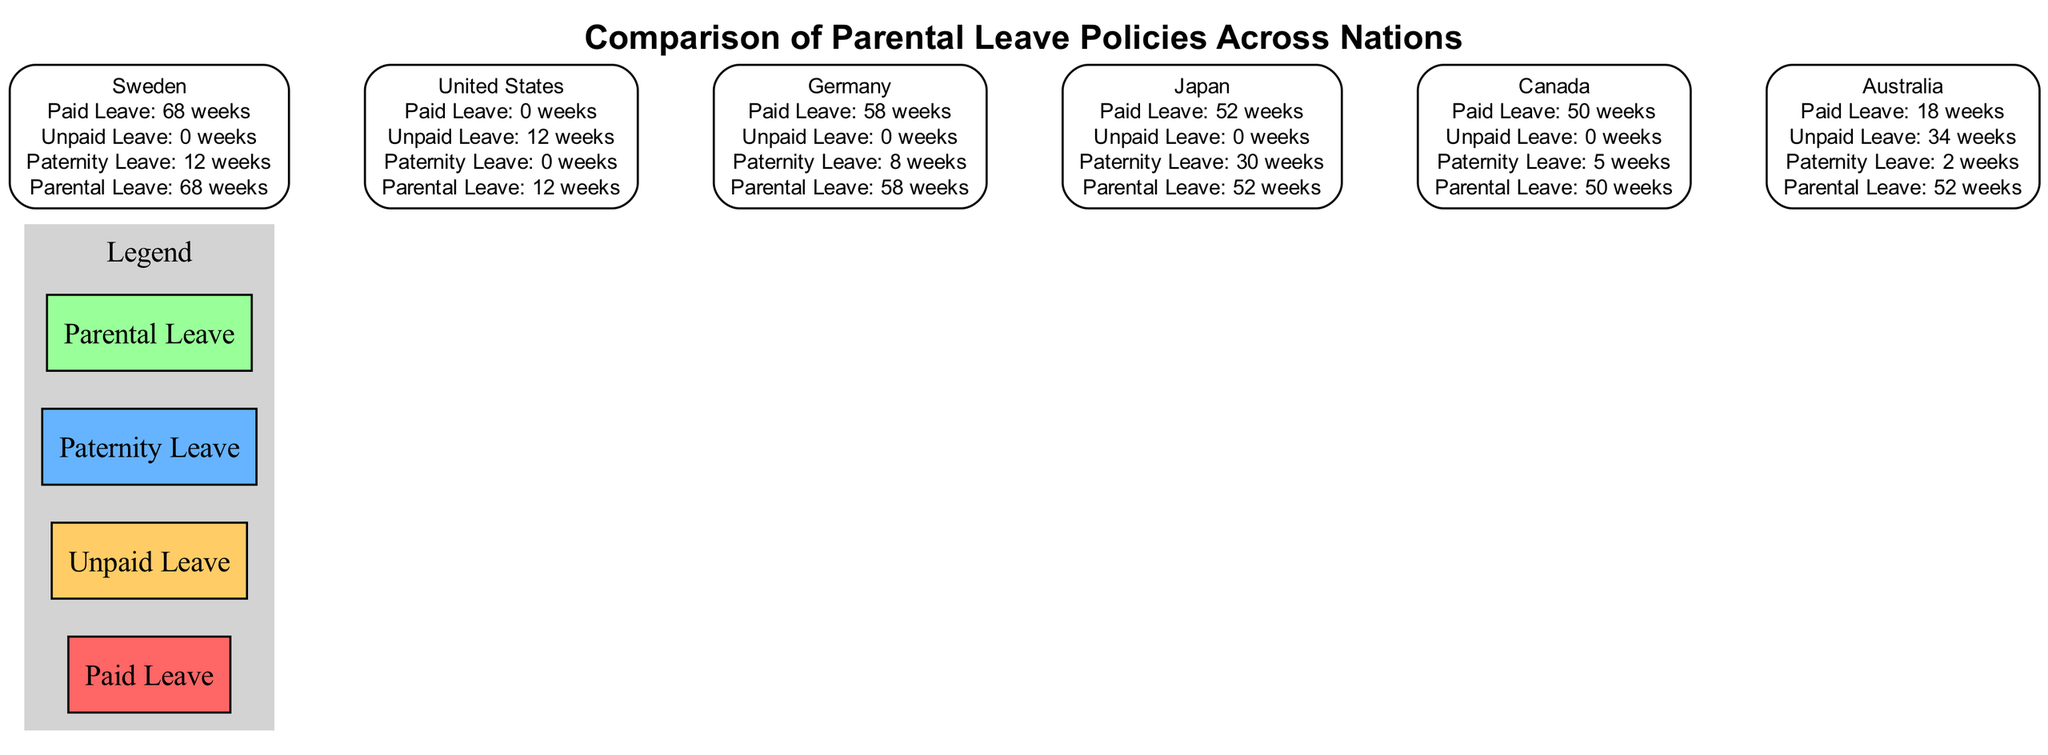What is the maximum number of weeks of paid leave offered by Sweden? In the diagram, Sweden has a label stating it offers 68 weeks of paid leave. By checking other countries, none exceed this value. Thus, Sweden is identified as the maximum.
Answer: 68 How many countries have unpaid leave greater than zero? The diagram shows Australia (34 weeks) and the United States (12 weeks) as the only countries with more than zero weeks of unpaid leave. Counting these, we find there are 2 countries.
Answer: 2 What is the total number of weeks of parental leave available in Japan? The diagram indicates that Japan has a total of 52 weeks of parental leave. This value is taken directly from the label corresponding to Japan.
Answer: 52 What country offers the least amount of paid leave? When reviewing the countries shown in the diagram, the United States is indicated to have 0 weeks of paid leave, which is the lowest compared to others.
Answer: United States Which country provides the most weeks of paternity leave? The diagram states that Japan has 30 weeks of paternity leave, which is the highest amount listed for any country, as none have more than this.
Answer: Japan How many total weeks of parental leave do Sweden and Germany provide combined? The diagram specifies Sweden with 68 weeks and Germany with 58 weeks of parental leave. Adding these two values together (68 + 58) results in a sum of 126 weeks.
Answer: 126 What color represents unpaid leave in the diagram's legend? The legend of the diagram indicates that unpaid leave is represented by the color #ffcc66. This specific color code is associated directly with unpaid leave.
Answer: #ffcc66 What is the relationship between paid leave and paternity leave in Canada? In the diagram, Canada has 50 weeks of paid leave and 5 weeks of paternity leave. The comparison suggests that Canada offers significantly more paid leave compared to its paternity leave.
Answer: More paid leave than paternity leave 